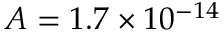Convert formula to latex. <formula><loc_0><loc_0><loc_500><loc_500>A = 1 . 7 \times 1 0 ^ { - 1 4 }</formula> 